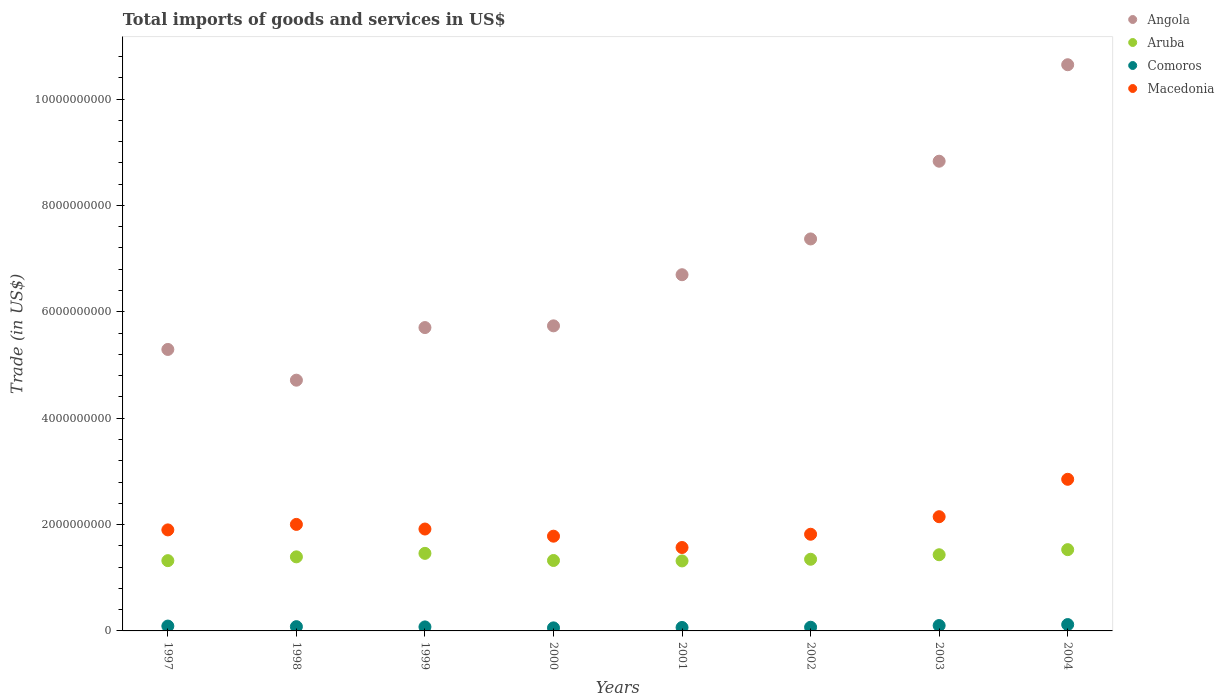How many different coloured dotlines are there?
Offer a very short reply. 4. What is the total imports of goods and services in Macedonia in 1997?
Offer a very short reply. 1.90e+09. Across all years, what is the maximum total imports of goods and services in Macedonia?
Offer a very short reply. 2.85e+09. Across all years, what is the minimum total imports of goods and services in Macedonia?
Make the answer very short. 1.57e+09. In which year was the total imports of goods and services in Macedonia maximum?
Your response must be concise. 2004. In which year was the total imports of goods and services in Macedonia minimum?
Your response must be concise. 2001. What is the total total imports of goods and services in Macedonia in the graph?
Ensure brevity in your answer.  1.60e+1. What is the difference between the total imports of goods and services in Angola in 2000 and that in 2001?
Ensure brevity in your answer.  -9.61e+08. What is the difference between the total imports of goods and services in Angola in 2004 and the total imports of goods and services in Aruba in 2002?
Give a very brief answer. 9.30e+09. What is the average total imports of goods and services in Angola per year?
Your response must be concise. 6.87e+09. In the year 2004, what is the difference between the total imports of goods and services in Macedonia and total imports of goods and services in Comoros?
Offer a very short reply. 2.73e+09. In how many years, is the total imports of goods and services in Macedonia greater than 8000000000 US$?
Ensure brevity in your answer.  0. What is the ratio of the total imports of goods and services in Comoros in 1999 to that in 2004?
Keep it short and to the point. 0.63. What is the difference between the highest and the second highest total imports of goods and services in Angola?
Your answer should be compact. 1.81e+09. What is the difference between the highest and the lowest total imports of goods and services in Macedonia?
Offer a terse response. 1.28e+09. In how many years, is the total imports of goods and services in Aruba greater than the average total imports of goods and services in Aruba taken over all years?
Your answer should be very brief. 4. Is it the case that in every year, the sum of the total imports of goods and services in Comoros and total imports of goods and services in Angola  is greater than the total imports of goods and services in Aruba?
Give a very brief answer. Yes. How many years are there in the graph?
Keep it short and to the point. 8. What is the difference between two consecutive major ticks on the Y-axis?
Ensure brevity in your answer.  2.00e+09. Are the values on the major ticks of Y-axis written in scientific E-notation?
Your response must be concise. No. Does the graph contain grids?
Provide a succinct answer. No. Where does the legend appear in the graph?
Offer a very short reply. Top right. How many legend labels are there?
Give a very brief answer. 4. What is the title of the graph?
Offer a very short reply. Total imports of goods and services in US$. What is the label or title of the X-axis?
Make the answer very short. Years. What is the label or title of the Y-axis?
Offer a terse response. Trade (in US$). What is the Trade (in US$) in Angola in 1997?
Make the answer very short. 5.29e+09. What is the Trade (in US$) of Aruba in 1997?
Offer a terse response. 1.32e+09. What is the Trade (in US$) of Comoros in 1997?
Offer a terse response. 9.13e+07. What is the Trade (in US$) in Macedonia in 1997?
Ensure brevity in your answer.  1.90e+09. What is the Trade (in US$) of Angola in 1998?
Your answer should be very brief. 4.71e+09. What is the Trade (in US$) in Aruba in 1998?
Give a very brief answer. 1.39e+09. What is the Trade (in US$) in Comoros in 1998?
Ensure brevity in your answer.  8.02e+07. What is the Trade (in US$) of Macedonia in 1998?
Provide a short and direct response. 2.00e+09. What is the Trade (in US$) in Angola in 1999?
Your answer should be compact. 5.70e+09. What is the Trade (in US$) of Aruba in 1999?
Make the answer very short. 1.46e+09. What is the Trade (in US$) of Comoros in 1999?
Offer a very short reply. 7.55e+07. What is the Trade (in US$) of Macedonia in 1999?
Your answer should be compact. 1.92e+09. What is the Trade (in US$) in Angola in 2000?
Your answer should be very brief. 5.74e+09. What is the Trade (in US$) in Aruba in 2000?
Give a very brief answer. 1.32e+09. What is the Trade (in US$) of Comoros in 2000?
Provide a short and direct response. 5.73e+07. What is the Trade (in US$) of Macedonia in 2000?
Offer a very short reply. 1.78e+09. What is the Trade (in US$) in Angola in 2001?
Keep it short and to the point. 6.70e+09. What is the Trade (in US$) of Aruba in 2001?
Your response must be concise. 1.32e+09. What is the Trade (in US$) in Comoros in 2001?
Provide a succinct answer. 6.50e+07. What is the Trade (in US$) of Macedonia in 2001?
Keep it short and to the point. 1.57e+09. What is the Trade (in US$) of Angola in 2002?
Offer a terse response. 7.37e+09. What is the Trade (in US$) of Aruba in 2002?
Provide a short and direct response. 1.35e+09. What is the Trade (in US$) in Comoros in 2002?
Keep it short and to the point. 6.95e+07. What is the Trade (in US$) of Macedonia in 2002?
Your answer should be very brief. 1.82e+09. What is the Trade (in US$) in Angola in 2003?
Provide a short and direct response. 8.83e+09. What is the Trade (in US$) in Aruba in 2003?
Ensure brevity in your answer.  1.43e+09. What is the Trade (in US$) of Comoros in 2003?
Offer a very short reply. 1.01e+08. What is the Trade (in US$) of Macedonia in 2003?
Your response must be concise. 2.15e+09. What is the Trade (in US$) in Angola in 2004?
Provide a short and direct response. 1.06e+1. What is the Trade (in US$) of Aruba in 2004?
Make the answer very short. 1.53e+09. What is the Trade (in US$) in Comoros in 2004?
Ensure brevity in your answer.  1.20e+08. What is the Trade (in US$) of Macedonia in 2004?
Offer a terse response. 2.85e+09. Across all years, what is the maximum Trade (in US$) in Angola?
Provide a succinct answer. 1.06e+1. Across all years, what is the maximum Trade (in US$) of Aruba?
Provide a succinct answer. 1.53e+09. Across all years, what is the maximum Trade (in US$) of Comoros?
Your answer should be very brief. 1.20e+08. Across all years, what is the maximum Trade (in US$) of Macedonia?
Provide a succinct answer. 2.85e+09. Across all years, what is the minimum Trade (in US$) in Angola?
Provide a short and direct response. 4.71e+09. Across all years, what is the minimum Trade (in US$) in Aruba?
Ensure brevity in your answer.  1.32e+09. Across all years, what is the minimum Trade (in US$) in Comoros?
Offer a very short reply. 5.73e+07. Across all years, what is the minimum Trade (in US$) of Macedonia?
Keep it short and to the point. 1.57e+09. What is the total Trade (in US$) in Angola in the graph?
Provide a short and direct response. 5.50e+1. What is the total Trade (in US$) in Aruba in the graph?
Keep it short and to the point. 1.11e+1. What is the total Trade (in US$) in Comoros in the graph?
Offer a very short reply. 6.59e+08. What is the total Trade (in US$) of Macedonia in the graph?
Your response must be concise. 1.60e+1. What is the difference between the Trade (in US$) of Angola in 1997 and that in 1998?
Ensure brevity in your answer.  5.78e+08. What is the difference between the Trade (in US$) in Aruba in 1997 and that in 1998?
Make the answer very short. -7.15e+07. What is the difference between the Trade (in US$) in Comoros in 1997 and that in 1998?
Your response must be concise. 1.10e+07. What is the difference between the Trade (in US$) of Macedonia in 1997 and that in 1998?
Provide a succinct answer. -1.03e+08. What is the difference between the Trade (in US$) of Angola in 1997 and that in 1999?
Keep it short and to the point. -4.11e+08. What is the difference between the Trade (in US$) of Aruba in 1997 and that in 1999?
Ensure brevity in your answer.  -1.37e+08. What is the difference between the Trade (in US$) in Comoros in 1997 and that in 1999?
Your response must be concise. 1.58e+07. What is the difference between the Trade (in US$) of Macedonia in 1997 and that in 1999?
Make the answer very short. -1.64e+07. What is the difference between the Trade (in US$) in Angola in 1997 and that in 2000?
Ensure brevity in your answer.  -4.44e+08. What is the difference between the Trade (in US$) of Aruba in 1997 and that in 2000?
Give a very brief answer. -3.06e+06. What is the difference between the Trade (in US$) of Comoros in 1997 and that in 2000?
Your answer should be compact. 3.40e+07. What is the difference between the Trade (in US$) in Macedonia in 1997 and that in 2000?
Your answer should be compact. 1.18e+08. What is the difference between the Trade (in US$) in Angola in 1997 and that in 2001?
Keep it short and to the point. -1.41e+09. What is the difference between the Trade (in US$) in Aruba in 1997 and that in 2001?
Your response must be concise. 5.20e+06. What is the difference between the Trade (in US$) of Comoros in 1997 and that in 2001?
Give a very brief answer. 2.63e+07. What is the difference between the Trade (in US$) in Macedonia in 1997 and that in 2001?
Offer a terse response. 3.31e+08. What is the difference between the Trade (in US$) of Angola in 1997 and that in 2002?
Your answer should be very brief. -2.08e+09. What is the difference between the Trade (in US$) of Aruba in 1997 and that in 2002?
Offer a terse response. -2.59e+07. What is the difference between the Trade (in US$) in Comoros in 1997 and that in 2002?
Your answer should be very brief. 2.18e+07. What is the difference between the Trade (in US$) of Macedonia in 1997 and that in 2002?
Your answer should be compact. 8.18e+07. What is the difference between the Trade (in US$) in Angola in 1997 and that in 2003?
Offer a very short reply. -3.54e+09. What is the difference between the Trade (in US$) in Aruba in 1997 and that in 2003?
Provide a short and direct response. -1.11e+08. What is the difference between the Trade (in US$) in Comoros in 1997 and that in 2003?
Make the answer very short. -9.95e+06. What is the difference between the Trade (in US$) of Macedonia in 1997 and that in 2003?
Make the answer very short. -2.48e+08. What is the difference between the Trade (in US$) of Angola in 1997 and that in 2004?
Give a very brief answer. -5.35e+09. What is the difference between the Trade (in US$) of Aruba in 1997 and that in 2004?
Offer a terse response. -2.07e+08. What is the difference between the Trade (in US$) in Comoros in 1997 and that in 2004?
Provide a succinct answer. -2.83e+07. What is the difference between the Trade (in US$) in Macedonia in 1997 and that in 2004?
Offer a terse response. -9.51e+08. What is the difference between the Trade (in US$) of Angola in 1998 and that in 1999?
Give a very brief answer. -9.89e+08. What is the difference between the Trade (in US$) of Aruba in 1998 and that in 1999?
Provide a succinct answer. -6.55e+07. What is the difference between the Trade (in US$) of Comoros in 1998 and that in 1999?
Ensure brevity in your answer.  4.76e+06. What is the difference between the Trade (in US$) of Macedonia in 1998 and that in 1999?
Ensure brevity in your answer.  8.71e+07. What is the difference between the Trade (in US$) of Angola in 1998 and that in 2000?
Ensure brevity in your answer.  -1.02e+09. What is the difference between the Trade (in US$) in Aruba in 1998 and that in 2000?
Your response must be concise. 6.85e+07. What is the difference between the Trade (in US$) of Comoros in 1998 and that in 2000?
Offer a very short reply. 2.29e+07. What is the difference between the Trade (in US$) in Macedonia in 1998 and that in 2000?
Your response must be concise. 2.22e+08. What is the difference between the Trade (in US$) in Angola in 1998 and that in 2001?
Make the answer very short. -1.98e+09. What is the difference between the Trade (in US$) in Aruba in 1998 and that in 2001?
Offer a very short reply. 7.67e+07. What is the difference between the Trade (in US$) of Comoros in 1998 and that in 2001?
Provide a short and direct response. 1.53e+07. What is the difference between the Trade (in US$) in Macedonia in 1998 and that in 2001?
Provide a succinct answer. 4.34e+08. What is the difference between the Trade (in US$) of Angola in 1998 and that in 2002?
Your answer should be compact. -2.66e+09. What is the difference between the Trade (in US$) in Aruba in 1998 and that in 2002?
Offer a terse response. 4.56e+07. What is the difference between the Trade (in US$) of Comoros in 1998 and that in 2002?
Offer a very short reply. 1.08e+07. What is the difference between the Trade (in US$) of Macedonia in 1998 and that in 2002?
Your response must be concise. 1.85e+08. What is the difference between the Trade (in US$) in Angola in 1998 and that in 2003?
Offer a terse response. -4.12e+09. What is the difference between the Trade (in US$) in Aruba in 1998 and that in 2003?
Your response must be concise. -3.94e+07. What is the difference between the Trade (in US$) in Comoros in 1998 and that in 2003?
Your response must be concise. -2.10e+07. What is the difference between the Trade (in US$) of Macedonia in 1998 and that in 2003?
Your answer should be very brief. -1.44e+08. What is the difference between the Trade (in US$) in Angola in 1998 and that in 2004?
Your answer should be very brief. -5.93e+09. What is the difference between the Trade (in US$) in Aruba in 1998 and that in 2004?
Make the answer very short. -1.35e+08. What is the difference between the Trade (in US$) of Comoros in 1998 and that in 2004?
Offer a very short reply. -3.93e+07. What is the difference between the Trade (in US$) of Macedonia in 1998 and that in 2004?
Your answer should be very brief. -8.48e+08. What is the difference between the Trade (in US$) in Angola in 1999 and that in 2000?
Make the answer very short. -3.23e+07. What is the difference between the Trade (in US$) in Aruba in 1999 and that in 2000?
Give a very brief answer. 1.34e+08. What is the difference between the Trade (in US$) of Comoros in 1999 and that in 2000?
Your response must be concise. 1.82e+07. What is the difference between the Trade (in US$) in Macedonia in 1999 and that in 2000?
Your answer should be compact. 1.34e+08. What is the difference between the Trade (in US$) in Angola in 1999 and that in 2001?
Keep it short and to the point. -9.94e+08. What is the difference between the Trade (in US$) in Aruba in 1999 and that in 2001?
Ensure brevity in your answer.  1.42e+08. What is the difference between the Trade (in US$) in Comoros in 1999 and that in 2001?
Give a very brief answer. 1.05e+07. What is the difference between the Trade (in US$) of Macedonia in 1999 and that in 2001?
Offer a terse response. 3.47e+08. What is the difference between the Trade (in US$) of Angola in 1999 and that in 2002?
Your response must be concise. -1.67e+09. What is the difference between the Trade (in US$) of Aruba in 1999 and that in 2002?
Offer a terse response. 1.11e+08. What is the difference between the Trade (in US$) in Comoros in 1999 and that in 2002?
Offer a terse response. 5.99e+06. What is the difference between the Trade (in US$) in Macedonia in 1999 and that in 2002?
Your answer should be compact. 9.81e+07. What is the difference between the Trade (in US$) of Angola in 1999 and that in 2003?
Make the answer very short. -3.13e+09. What is the difference between the Trade (in US$) in Aruba in 1999 and that in 2003?
Your answer should be very brief. 2.60e+07. What is the difference between the Trade (in US$) in Comoros in 1999 and that in 2003?
Your response must be concise. -2.57e+07. What is the difference between the Trade (in US$) in Macedonia in 1999 and that in 2003?
Provide a succinct answer. -2.32e+08. What is the difference between the Trade (in US$) of Angola in 1999 and that in 2004?
Your answer should be very brief. -4.94e+09. What is the difference between the Trade (in US$) of Aruba in 1999 and that in 2004?
Offer a terse response. -6.98e+07. What is the difference between the Trade (in US$) of Comoros in 1999 and that in 2004?
Offer a terse response. -4.40e+07. What is the difference between the Trade (in US$) of Macedonia in 1999 and that in 2004?
Offer a very short reply. -9.35e+08. What is the difference between the Trade (in US$) of Angola in 2000 and that in 2001?
Provide a succinct answer. -9.61e+08. What is the difference between the Trade (in US$) in Aruba in 2000 and that in 2001?
Offer a terse response. 8.25e+06. What is the difference between the Trade (in US$) in Comoros in 2000 and that in 2001?
Make the answer very short. -7.68e+06. What is the difference between the Trade (in US$) of Macedonia in 2000 and that in 2001?
Keep it short and to the point. 2.13e+08. What is the difference between the Trade (in US$) of Angola in 2000 and that in 2002?
Make the answer very short. -1.63e+09. What is the difference between the Trade (in US$) in Aruba in 2000 and that in 2002?
Keep it short and to the point. -2.28e+07. What is the difference between the Trade (in US$) of Comoros in 2000 and that in 2002?
Ensure brevity in your answer.  -1.22e+07. What is the difference between the Trade (in US$) of Macedonia in 2000 and that in 2002?
Your answer should be compact. -3.63e+07. What is the difference between the Trade (in US$) in Angola in 2000 and that in 2003?
Offer a terse response. -3.10e+09. What is the difference between the Trade (in US$) of Aruba in 2000 and that in 2003?
Give a very brief answer. -1.08e+08. What is the difference between the Trade (in US$) of Comoros in 2000 and that in 2003?
Ensure brevity in your answer.  -4.39e+07. What is the difference between the Trade (in US$) of Macedonia in 2000 and that in 2003?
Give a very brief answer. -3.66e+08. What is the difference between the Trade (in US$) in Angola in 2000 and that in 2004?
Keep it short and to the point. -4.91e+09. What is the difference between the Trade (in US$) in Aruba in 2000 and that in 2004?
Provide a short and direct response. -2.04e+08. What is the difference between the Trade (in US$) in Comoros in 2000 and that in 2004?
Ensure brevity in your answer.  -6.22e+07. What is the difference between the Trade (in US$) of Macedonia in 2000 and that in 2004?
Ensure brevity in your answer.  -1.07e+09. What is the difference between the Trade (in US$) of Angola in 2001 and that in 2002?
Make the answer very short. -6.73e+08. What is the difference between the Trade (in US$) in Aruba in 2001 and that in 2002?
Provide a succinct answer. -3.11e+07. What is the difference between the Trade (in US$) of Comoros in 2001 and that in 2002?
Offer a very short reply. -4.51e+06. What is the difference between the Trade (in US$) of Macedonia in 2001 and that in 2002?
Offer a terse response. -2.49e+08. What is the difference between the Trade (in US$) in Angola in 2001 and that in 2003?
Your response must be concise. -2.13e+09. What is the difference between the Trade (in US$) of Aruba in 2001 and that in 2003?
Provide a short and direct response. -1.16e+08. What is the difference between the Trade (in US$) of Comoros in 2001 and that in 2003?
Provide a succinct answer. -3.62e+07. What is the difference between the Trade (in US$) of Macedonia in 2001 and that in 2003?
Your answer should be compact. -5.79e+08. What is the difference between the Trade (in US$) in Angola in 2001 and that in 2004?
Your answer should be very brief. -3.95e+09. What is the difference between the Trade (in US$) of Aruba in 2001 and that in 2004?
Your answer should be very brief. -2.12e+08. What is the difference between the Trade (in US$) in Comoros in 2001 and that in 2004?
Provide a succinct answer. -5.45e+07. What is the difference between the Trade (in US$) of Macedonia in 2001 and that in 2004?
Your answer should be very brief. -1.28e+09. What is the difference between the Trade (in US$) in Angola in 2002 and that in 2003?
Your response must be concise. -1.46e+09. What is the difference between the Trade (in US$) of Aruba in 2002 and that in 2003?
Your response must be concise. -8.50e+07. What is the difference between the Trade (in US$) of Comoros in 2002 and that in 2003?
Offer a terse response. -3.17e+07. What is the difference between the Trade (in US$) of Macedonia in 2002 and that in 2003?
Provide a short and direct response. -3.30e+08. What is the difference between the Trade (in US$) of Angola in 2002 and that in 2004?
Give a very brief answer. -3.28e+09. What is the difference between the Trade (in US$) of Aruba in 2002 and that in 2004?
Provide a short and direct response. -1.81e+08. What is the difference between the Trade (in US$) of Comoros in 2002 and that in 2004?
Offer a terse response. -5.00e+07. What is the difference between the Trade (in US$) in Macedonia in 2002 and that in 2004?
Offer a terse response. -1.03e+09. What is the difference between the Trade (in US$) of Angola in 2003 and that in 2004?
Make the answer very short. -1.81e+09. What is the difference between the Trade (in US$) in Aruba in 2003 and that in 2004?
Give a very brief answer. -9.58e+07. What is the difference between the Trade (in US$) of Comoros in 2003 and that in 2004?
Your response must be concise. -1.83e+07. What is the difference between the Trade (in US$) of Macedonia in 2003 and that in 2004?
Your answer should be compact. -7.03e+08. What is the difference between the Trade (in US$) in Angola in 1997 and the Trade (in US$) in Aruba in 1998?
Offer a terse response. 3.90e+09. What is the difference between the Trade (in US$) in Angola in 1997 and the Trade (in US$) in Comoros in 1998?
Offer a terse response. 5.21e+09. What is the difference between the Trade (in US$) in Angola in 1997 and the Trade (in US$) in Macedonia in 1998?
Provide a short and direct response. 3.29e+09. What is the difference between the Trade (in US$) in Aruba in 1997 and the Trade (in US$) in Comoros in 1998?
Offer a terse response. 1.24e+09. What is the difference between the Trade (in US$) in Aruba in 1997 and the Trade (in US$) in Macedonia in 1998?
Your answer should be very brief. -6.82e+08. What is the difference between the Trade (in US$) in Comoros in 1997 and the Trade (in US$) in Macedonia in 1998?
Provide a short and direct response. -1.91e+09. What is the difference between the Trade (in US$) in Angola in 1997 and the Trade (in US$) in Aruba in 1999?
Keep it short and to the point. 3.83e+09. What is the difference between the Trade (in US$) of Angola in 1997 and the Trade (in US$) of Comoros in 1999?
Your response must be concise. 5.22e+09. What is the difference between the Trade (in US$) in Angola in 1997 and the Trade (in US$) in Macedonia in 1999?
Offer a terse response. 3.38e+09. What is the difference between the Trade (in US$) of Aruba in 1997 and the Trade (in US$) of Comoros in 1999?
Your answer should be compact. 1.25e+09. What is the difference between the Trade (in US$) of Aruba in 1997 and the Trade (in US$) of Macedonia in 1999?
Offer a terse response. -5.95e+08. What is the difference between the Trade (in US$) of Comoros in 1997 and the Trade (in US$) of Macedonia in 1999?
Your response must be concise. -1.82e+09. What is the difference between the Trade (in US$) in Angola in 1997 and the Trade (in US$) in Aruba in 2000?
Your response must be concise. 3.97e+09. What is the difference between the Trade (in US$) of Angola in 1997 and the Trade (in US$) of Comoros in 2000?
Ensure brevity in your answer.  5.23e+09. What is the difference between the Trade (in US$) of Angola in 1997 and the Trade (in US$) of Macedonia in 2000?
Your answer should be compact. 3.51e+09. What is the difference between the Trade (in US$) in Aruba in 1997 and the Trade (in US$) in Comoros in 2000?
Provide a short and direct response. 1.26e+09. What is the difference between the Trade (in US$) in Aruba in 1997 and the Trade (in US$) in Macedonia in 2000?
Provide a short and direct response. -4.60e+08. What is the difference between the Trade (in US$) in Comoros in 1997 and the Trade (in US$) in Macedonia in 2000?
Your answer should be compact. -1.69e+09. What is the difference between the Trade (in US$) of Angola in 1997 and the Trade (in US$) of Aruba in 2001?
Ensure brevity in your answer.  3.98e+09. What is the difference between the Trade (in US$) of Angola in 1997 and the Trade (in US$) of Comoros in 2001?
Provide a short and direct response. 5.23e+09. What is the difference between the Trade (in US$) in Angola in 1997 and the Trade (in US$) in Macedonia in 2001?
Give a very brief answer. 3.72e+09. What is the difference between the Trade (in US$) in Aruba in 1997 and the Trade (in US$) in Comoros in 2001?
Keep it short and to the point. 1.26e+09. What is the difference between the Trade (in US$) in Aruba in 1997 and the Trade (in US$) in Macedonia in 2001?
Offer a terse response. -2.47e+08. What is the difference between the Trade (in US$) in Comoros in 1997 and the Trade (in US$) in Macedonia in 2001?
Your answer should be very brief. -1.48e+09. What is the difference between the Trade (in US$) in Angola in 1997 and the Trade (in US$) in Aruba in 2002?
Provide a short and direct response. 3.95e+09. What is the difference between the Trade (in US$) of Angola in 1997 and the Trade (in US$) of Comoros in 2002?
Your response must be concise. 5.22e+09. What is the difference between the Trade (in US$) of Angola in 1997 and the Trade (in US$) of Macedonia in 2002?
Offer a terse response. 3.47e+09. What is the difference between the Trade (in US$) in Aruba in 1997 and the Trade (in US$) in Comoros in 2002?
Keep it short and to the point. 1.25e+09. What is the difference between the Trade (in US$) of Aruba in 1997 and the Trade (in US$) of Macedonia in 2002?
Offer a terse response. -4.96e+08. What is the difference between the Trade (in US$) of Comoros in 1997 and the Trade (in US$) of Macedonia in 2002?
Keep it short and to the point. -1.73e+09. What is the difference between the Trade (in US$) of Angola in 1997 and the Trade (in US$) of Aruba in 2003?
Make the answer very short. 3.86e+09. What is the difference between the Trade (in US$) in Angola in 1997 and the Trade (in US$) in Comoros in 2003?
Your answer should be compact. 5.19e+09. What is the difference between the Trade (in US$) of Angola in 1997 and the Trade (in US$) of Macedonia in 2003?
Your answer should be compact. 3.14e+09. What is the difference between the Trade (in US$) in Aruba in 1997 and the Trade (in US$) in Comoros in 2003?
Keep it short and to the point. 1.22e+09. What is the difference between the Trade (in US$) of Aruba in 1997 and the Trade (in US$) of Macedonia in 2003?
Your answer should be compact. -8.26e+08. What is the difference between the Trade (in US$) of Comoros in 1997 and the Trade (in US$) of Macedonia in 2003?
Offer a very short reply. -2.06e+09. What is the difference between the Trade (in US$) of Angola in 1997 and the Trade (in US$) of Aruba in 2004?
Offer a terse response. 3.76e+09. What is the difference between the Trade (in US$) of Angola in 1997 and the Trade (in US$) of Comoros in 2004?
Ensure brevity in your answer.  5.17e+09. What is the difference between the Trade (in US$) in Angola in 1997 and the Trade (in US$) in Macedonia in 2004?
Provide a succinct answer. 2.44e+09. What is the difference between the Trade (in US$) in Aruba in 1997 and the Trade (in US$) in Comoros in 2004?
Your answer should be compact. 1.20e+09. What is the difference between the Trade (in US$) in Aruba in 1997 and the Trade (in US$) in Macedonia in 2004?
Your response must be concise. -1.53e+09. What is the difference between the Trade (in US$) of Comoros in 1997 and the Trade (in US$) of Macedonia in 2004?
Ensure brevity in your answer.  -2.76e+09. What is the difference between the Trade (in US$) of Angola in 1998 and the Trade (in US$) of Aruba in 1999?
Your response must be concise. 3.26e+09. What is the difference between the Trade (in US$) of Angola in 1998 and the Trade (in US$) of Comoros in 1999?
Provide a succinct answer. 4.64e+09. What is the difference between the Trade (in US$) of Angola in 1998 and the Trade (in US$) of Macedonia in 1999?
Offer a terse response. 2.80e+09. What is the difference between the Trade (in US$) in Aruba in 1998 and the Trade (in US$) in Comoros in 1999?
Offer a terse response. 1.32e+09. What is the difference between the Trade (in US$) in Aruba in 1998 and the Trade (in US$) in Macedonia in 1999?
Provide a short and direct response. -5.23e+08. What is the difference between the Trade (in US$) of Comoros in 1998 and the Trade (in US$) of Macedonia in 1999?
Ensure brevity in your answer.  -1.84e+09. What is the difference between the Trade (in US$) in Angola in 1998 and the Trade (in US$) in Aruba in 2000?
Keep it short and to the point. 3.39e+09. What is the difference between the Trade (in US$) of Angola in 1998 and the Trade (in US$) of Comoros in 2000?
Keep it short and to the point. 4.66e+09. What is the difference between the Trade (in US$) of Angola in 1998 and the Trade (in US$) of Macedonia in 2000?
Your answer should be very brief. 2.93e+09. What is the difference between the Trade (in US$) in Aruba in 1998 and the Trade (in US$) in Comoros in 2000?
Offer a very short reply. 1.34e+09. What is the difference between the Trade (in US$) in Aruba in 1998 and the Trade (in US$) in Macedonia in 2000?
Give a very brief answer. -3.89e+08. What is the difference between the Trade (in US$) in Comoros in 1998 and the Trade (in US$) in Macedonia in 2000?
Ensure brevity in your answer.  -1.70e+09. What is the difference between the Trade (in US$) of Angola in 1998 and the Trade (in US$) of Aruba in 2001?
Provide a succinct answer. 3.40e+09. What is the difference between the Trade (in US$) of Angola in 1998 and the Trade (in US$) of Comoros in 2001?
Your answer should be very brief. 4.65e+09. What is the difference between the Trade (in US$) of Angola in 1998 and the Trade (in US$) of Macedonia in 2001?
Provide a short and direct response. 3.15e+09. What is the difference between the Trade (in US$) in Aruba in 1998 and the Trade (in US$) in Comoros in 2001?
Offer a terse response. 1.33e+09. What is the difference between the Trade (in US$) in Aruba in 1998 and the Trade (in US$) in Macedonia in 2001?
Give a very brief answer. -1.76e+08. What is the difference between the Trade (in US$) of Comoros in 1998 and the Trade (in US$) of Macedonia in 2001?
Your answer should be compact. -1.49e+09. What is the difference between the Trade (in US$) in Angola in 1998 and the Trade (in US$) in Aruba in 2002?
Offer a very short reply. 3.37e+09. What is the difference between the Trade (in US$) of Angola in 1998 and the Trade (in US$) of Comoros in 2002?
Offer a very short reply. 4.64e+09. What is the difference between the Trade (in US$) in Angola in 1998 and the Trade (in US$) in Macedonia in 2002?
Your response must be concise. 2.90e+09. What is the difference between the Trade (in US$) in Aruba in 1998 and the Trade (in US$) in Comoros in 2002?
Your answer should be compact. 1.32e+09. What is the difference between the Trade (in US$) of Aruba in 1998 and the Trade (in US$) of Macedonia in 2002?
Provide a short and direct response. -4.25e+08. What is the difference between the Trade (in US$) of Comoros in 1998 and the Trade (in US$) of Macedonia in 2002?
Ensure brevity in your answer.  -1.74e+09. What is the difference between the Trade (in US$) in Angola in 1998 and the Trade (in US$) in Aruba in 2003?
Your answer should be compact. 3.28e+09. What is the difference between the Trade (in US$) in Angola in 1998 and the Trade (in US$) in Comoros in 2003?
Offer a very short reply. 4.61e+09. What is the difference between the Trade (in US$) of Angola in 1998 and the Trade (in US$) of Macedonia in 2003?
Keep it short and to the point. 2.57e+09. What is the difference between the Trade (in US$) of Aruba in 1998 and the Trade (in US$) of Comoros in 2003?
Keep it short and to the point. 1.29e+09. What is the difference between the Trade (in US$) of Aruba in 1998 and the Trade (in US$) of Macedonia in 2003?
Offer a terse response. -7.55e+08. What is the difference between the Trade (in US$) in Comoros in 1998 and the Trade (in US$) in Macedonia in 2003?
Provide a succinct answer. -2.07e+09. What is the difference between the Trade (in US$) of Angola in 1998 and the Trade (in US$) of Aruba in 2004?
Provide a short and direct response. 3.19e+09. What is the difference between the Trade (in US$) of Angola in 1998 and the Trade (in US$) of Comoros in 2004?
Give a very brief answer. 4.59e+09. What is the difference between the Trade (in US$) in Angola in 1998 and the Trade (in US$) in Macedonia in 2004?
Provide a short and direct response. 1.86e+09. What is the difference between the Trade (in US$) in Aruba in 1998 and the Trade (in US$) in Comoros in 2004?
Give a very brief answer. 1.27e+09. What is the difference between the Trade (in US$) of Aruba in 1998 and the Trade (in US$) of Macedonia in 2004?
Make the answer very short. -1.46e+09. What is the difference between the Trade (in US$) in Comoros in 1998 and the Trade (in US$) in Macedonia in 2004?
Your answer should be compact. -2.77e+09. What is the difference between the Trade (in US$) of Angola in 1999 and the Trade (in US$) of Aruba in 2000?
Your response must be concise. 4.38e+09. What is the difference between the Trade (in US$) of Angola in 1999 and the Trade (in US$) of Comoros in 2000?
Ensure brevity in your answer.  5.65e+09. What is the difference between the Trade (in US$) in Angola in 1999 and the Trade (in US$) in Macedonia in 2000?
Your response must be concise. 3.92e+09. What is the difference between the Trade (in US$) of Aruba in 1999 and the Trade (in US$) of Comoros in 2000?
Provide a short and direct response. 1.40e+09. What is the difference between the Trade (in US$) of Aruba in 1999 and the Trade (in US$) of Macedonia in 2000?
Provide a succinct answer. -3.23e+08. What is the difference between the Trade (in US$) in Comoros in 1999 and the Trade (in US$) in Macedonia in 2000?
Offer a very short reply. -1.71e+09. What is the difference between the Trade (in US$) of Angola in 1999 and the Trade (in US$) of Aruba in 2001?
Provide a succinct answer. 4.39e+09. What is the difference between the Trade (in US$) in Angola in 1999 and the Trade (in US$) in Comoros in 2001?
Offer a terse response. 5.64e+09. What is the difference between the Trade (in US$) in Angola in 1999 and the Trade (in US$) in Macedonia in 2001?
Keep it short and to the point. 4.14e+09. What is the difference between the Trade (in US$) in Aruba in 1999 and the Trade (in US$) in Comoros in 2001?
Offer a very short reply. 1.39e+09. What is the difference between the Trade (in US$) in Aruba in 1999 and the Trade (in US$) in Macedonia in 2001?
Give a very brief answer. -1.10e+08. What is the difference between the Trade (in US$) of Comoros in 1999 and the Trade (in US$) of Macedonia in 2001?
Your response must be concise. -1.49e+09. What is the difference between the Trade (in US$) in Angola in 1999 and the Trade (in US$) in Aruba in 2002?
Your answer should be compact. 4.36e+09. What is the difference between the Trade (in US$) in Angola in 1999 and the Trade (in US$) in Comoros in 2002?
Your answer should be very brief. 5.63e+09. What is the difference between the Trade (in US$) in Angola in 1999 and the Trade (in US$) in Macedonia in 2002?
Give a very brief answer. 3.89e+09. What is the difference between the Trade (in US$) of Aruba in 1999 and the Trade (in US$) of Comoros in 2002?
Provide a succinct answer. 1.39e+09. What is the difference between the Trade (in US$) in Aruba in 1999 and the Trade (in US$) in Macedonia in 2002?
Make the answer very short. -3.59e+08. What is the difference between the Trade (in US$) in Comoros in 1999 and the Trade (in US$) in Macedonia in 2002?
Provide a succinct answer. -1.74e+09. What is the difference between the Trade (in US$) of Angola in 1999 and the Trade (in US$) of Aruba in 2003?
Your answer should be very brief. 4.27e+09. What is the difference between the Trade (in US$) in Angola in 1999 and the Trade (in US$) in Comoros in 2003?
Offer a terse response. 5.60e+09. What is the difference between the Trade (in US$) in Angola in 1999 and the Trade (in US$) in Macedonia in 2003?
Keep it short and to the point. 3.56e+09. What is the difference between the Trade (in US$) in Aruba in 1999 and the Trade (in US$) in Comoros in 2003?
Offer a very short reply. 1.36e+09. What is the difference between the Trade (in US$) of Aruba in 1999 and the Trade (in US$) of Macedonia in 2003?
Your response must be concise. -6.89e+08. What is the difference between the Trade (in US$) in Comoros in 1999 and the Trade (in US$) in Macedonia in 2003?
Provide a succinct answer. -2.07e+09. What is the difference between the Trade (in US$) of Angola in 1999 and the Trade (in US$) of Aruba in 2004?
Provide a succinct answer. 4.18e+09. What is the difference between the Trade (in US$) in Angola in 1999 and the Trade (in US$) in Comoros in 2004?
Offer a very short reply. 5.58e+09. What is the difference between the Trade (in US$) in Angola in 1999 and the Trade (in US$) in Macedonia in 2004?
Your answer should be compact. 2.85e+09. What is the difference between the Trade (in US$) of Aruba in 1999 and the Trade (in US$) of Comoros in 2004?
Ensure brevity in your answer.  1.34e+09. What is the difference between the Trade (in US$) of Aruba in 1999 and the Trade (in US$) of Macedonia in 2004?
Give a very brief answer. -1.39e+09. What is the difference between the Trade (in US$) in Comoros in 1999 and the Trade (in US$) in Macedonia in 2004?
Ensure brevity in your answer.  -2.78e+09. What is the difference between the Trade (in US$) in Angola in 2000 and the Trade (in US$) in Aruba in 2001?
Keep it short and to the point. 4.42e+09. What is the difference between the Trade (in US$) of Angola in 2000 and the Trade (in US$) of Comoros in 2001?
Give a very brief answer. 5.67e+09. What is the difference between the Trade (in US$) of Angola in 2000 and the Trade (in US$) of Macedonia in 2001?
Give a very brief answer. 4.17e+09. What is the difference between the Trade (in US$) in Aruba in 2000 and the Trade (in US$) in Comoros in 2001?
Your answer should be very brief. 1.26e+09. What is the difference between the Trade (in US$) of Aruba in 2000 and the Trade (in US$) of Macedonia in 2001?
Provide a short and direct response. -2.44e+08. What is the difference between the Trade (in US$) of Comoros in 2000 and the Trade (in US$) of Macedonia in 2001?
Offer a terse response. -1.51e+09. What is the difference between the Trade (in US$) of Angola in 2000 and the Trade (in US$) of Aruba in 2002?
Offer a very short reply. 4.39e+09. What is the difference between the Trade (in US$) of Angola in 2000 and the Trade (in US$) of Comoros in 2002?
Provide a succinct answer. 5.67e+09. What is the difference between the Trade (in US$) of Angola in 2000 and the Trade (in US$) of Macedonia in 2002?
Give a very brief answer. 3.92e+09. What is the difference between the Trade (in US$) of Aruba in 2000 and the Trade (in US$) of Comoros in 2002?
Offer a very short reply. 1.25e+09. What is the difference between the Trade (in US$) of Aruba in 2000 and the Trade (in US$) of Macedonia in 2002?
Offer a terse response. -4.93e+08. What is the difference between the Trade (in US$) of Comoros in 2000 and the Trade (in US$) of Macedonia in 2002?
Provide a short and direct response. -1.76e+09. What is the difference between the Trade (in US$) of Angola in 2000 and the Trade (in US$) of Aruba in 2003?
Provide a short and direct response. 4.30e+09. What is the difference between the Trade (in US$) in Angola in 2000 and the Trade (in US$) in Comoros in 2003?
Provide a short and direct response. 5.63e+09. What is the difference between the Trade (in US$) of Angola in 2000 and the Trade (in US$) of Macedonia in 2003?
Your answer should be compact. 3.59e+09. What is the difference between the Trade (in US$) in Aruba in 2000 and the Trade (in US$) in Comoros in 2003?
Keep it short and to the point. 1.22e+09. What is the difference between the Trade (in US$) of Aruba in 2000 and the Trade (in US$) of Macedonia in 2003?
Ensure brevity in your answer.  -8.23e+08. What is the difference between the Trade (in US$) in Comoros in 2000 and the Trade (in US$) in Macedonia in 2003?
Your response must be concise. -2.09e+09. What is the difference between the Trade (in US$) in Angola in 2000 and the Trade (in US$) in Aruba in 2004?
Provide a short and direct response. 4.21e+09. What is the difference between the Trade (in US$) of Angola in 2000 and the Trade (in US$) of Comoros in 2004?
Make the answer very short. 5.62e+09. What is the difference between the Trade (in US$) in Angola in 2000 and the Trade (in US$) in Macedonia in 2004?
Your response must be concise. 2.89e+09. What is the difference between the Trade (in US$) in Aruba in 2000 and the Trade (in US$) in Comoros in 2004?
Your answer should be compact. 1.20e+09. What is the difference between the Trade (in US$) in Aruba in 2000 and the Trade (in US$) in Macedonia in 2004?
Offer a terse response. -1.53e+09. What is the difference between the Trade (in US$) of Comoros in 2000 and the Trade (in US$) of Macedonia in 2004?
Give a very brief answer. -2.79e+09. What is the difference between the Trade (in US$) of Angola in 2001 and the Trade (in US$) of Aruba in 2002?
Your answer should be compact. 5.35e+09. What is the difference between the Trade (in US$) in Angola in 2001 and the Trade (in US$) in Comoros in 2002?
Your answer should be very brief. 6.63e+09. What is the difference between the Trade (in US$) in Angola in 2001 and the Trade (in US$) in Macedonia in 2002?
Offer a terse response. 4.88e+09. What is the difference between the Trade (in US$) of Aruba in 2001 and the Trade (in US$) of Comoros in 2002?
Keep it short and to the point. 1.25e+09. What is the difference between the Trade (in US$) in Aruba in 2001 and the Trade (in US$) in Macedonia in 2002?
Your answer should be very brief. -5.02e+08. What is the difference between the Trade (in US$) in Comoros in 2001 and the Trade (in US$) in Macedonia in 2002?
Your answer should be compact. -1.75e+09. What is the difference between the Trade (in US$) in Angola in 2001 and the Trade (in US$) in Aruba in 2003?
Your response must be concise. 5.27e+09. What is the difference between the Trade (in US$) of Angola in 2001 and the Trade (in US$) of Comoros in 2003?
Provide a short and direct response. 6.60e+09. What is the difference between the Trade (in US$) in Angola in 2001 and the Trade (in US$) in Macedonia in 2003?
Your answer should be very brief. 4.55e+09. What is the difference between the Trade (in US$) in Aruba in 2001 and the Trade (in US$) in Comoros in 2003?
Your response must be concise. 1.21e+09. What is the difference between the Trade (in US$) in Aruba in 2001 and the Trade (in US$) in Macedonia in 2003?
Provide a succinct answer. -8.31e+08. What is the difference between the Trade (in US$) of Comoros in 2001 and the Trade (in US$) of Macedonia in 2003?
Your answer should be compact. -2.08e+09. What is the difference between the Trade (in US$) of Angola in 2001 and the Trade (in US$) of Aruba in 2004?
Give a very brief answer. 5.17e+09. What is the difference between the Trade (in US$) in Angola in 2001 and the Trade (in US$) in Comoros in 2004?
Your response must be concise. 6.58e+09. What is the difference between the Trade (in US$) in Angola in 2001 and the Trade (in US$) in Macedonia in 2004?
Your response must be concise. 3.85e+09. What is the difference between the Trade (in US$) in Aruba in 2001 and the Trade (in US$) in Comoros in 2004?
Keep it short and to the point. 1.20e+09. What is the difference between the Trade (in US$) of Aruba in 2001 and the Trade (in US$) of Macedonia in 2004?
Offer a very short reply. -1.53e+09. What is the difference between the Trade (in US$) in Comoros in 2001 and the Trade (in US$) in Macedonia in 2004?
Your response must be concise. -2.79e+09. What is the difference between the Trade (in US$) of Angola in 2002 and the Trade (in US$) of Aruba in 2003?
Ensure brevity in your answer.  5.94e+09. What is the difference between the Trade (in US$) of Angola in 2002 and the Trade (in US$) of Comoros in 2003?
Your answer should be very brief. 7.27e+09. What is the difference between the Trade (in US$) in Angola in 2002 and the Trade (in US$) in Macedonia in 2003?
Provide a succinct answer. 5.22e+09. What is the difference between the Trade (in US$) in Aruba in 2002 and the Trade (in US$) in Comoros in 2003?
Keep it short and to the point. 1.25e+09. What is the difference between the Trade (in US$) of Aruba in 2002 and the Trade (in US$) of Macedonia in 2003?
Offer a terse response. -8.00e+08. What is the difference between the Trade (in US$) in Comoros in 2002 and the Trade (in US$) in Macedonia in 2003?
Your answer should be compact. -2.08e+09. What is the difference between the Trade (in US$) of Angola in 2002 and the Trade (in US$) of Aruba in 2004?
Your answer should be compact. 5.84e+09. What is the difference between the Trade (in US$) in Angola in 2002 and the Trade (in US$) in Comoros in 2004?
Your response must be concise. 7.25e+09. What is the difference between the Trade (in US$) of Angola in 2002 and the Trade (in US$) of Macedonia in 2004?
Your response must be concise. 4.52e+09. What is the difference between the Trade (in US$) in Aruba in 2002 and the Trade (in US$) in Comoros in 2004?
Offer a very short reply. 1.23e+09. What is the difference between the Trade (in US$) of Aruba in 2002 and the Trade (in US$) of Macedonia in 2004?
Give a very brief answer. -1.50e+09. What is the difference between the Trade (in US$) in Comoros in 2002 and the Trade (in US$) in Macedonia in 2004?
Your response must be concise. -2.78e+09. What is the difference between the Trade (in US$) of Angola in 2003 and the Trade (in US$) of Aruba in 2004?
Give a very brief answer. 7.30e+09. What is the difference between the Trade (in US$) of Angola in 2003 and the Trade (in US$) of Comoros in 2004?
Make the answer very short. 8.71e+09. What is the difference between the Trade (in US$) of Angola in 2003 and the Trade (in US$) of Macedonia in 2004?
Make the answer very short. 5.98e+09. What is the difference between the Trade (in US$) of Aruba in 2003 and the Trade (in US$) of Comoros in 2004?
Keep it short and to the point. 1.31e+09. What is the difference between the Trade (in US$) in Aruba in 2003 and the Trade (in US$) in Macedonia in 2004?
Provide a succinct answer. -1.42e+09. What is the difference between the Trade (in US$) of Comoros in 2003 and the Trade (in US$) of Macedonia in 2004?
Keep it short and to the point. -2.75e+09. What is the average Trade (in US$) in Angola per year?
Give a very brief answer. 6.87e+09. What is the average Trade (in US$) of Aruba per year?
Your response must be concise. 1.39e+09. What is the average Trade (in US$) of Comoros per year?
Keep it short and to the point. 8.24e+07. What is the average Trade (in US$) of Macedonia per year?
Your response must be concise. 2.00e+09. In the year 1997, what is the difference between the Trade (in US$) in Angola and Trade (in US$) in Aruba?
Provide a short and direct response. 3.97e+09. In the year 1997, what is the difference between the Trade (in US$) in Angola and Trade (in US$) in Comoros?
Your response must be concise. 5.20e+09. In the year 1997, what is the difference between the Trade (in US$) of Angola and Trade (in US$) of Macedonia?
Offer a terse response. 3.39e+09. In the year 1997, what is the difference between the Trade (in US$) of Aruba and Trade (in US$) of Comoros?
Your answer should be compact. 1.23e+09. In the year 1997, what is the difference between the Trade (in US$) in Aruba and Trade (in US$) in Macedonia?
Your answer should be compact. -5.78e+08. In the year 1997, what is the difference between the Trade (in US$) of Comoros and Trade (in US$) of Macedonia?
Provide a short and direct response. -1.81e+09. In the year 1998, what is the difference between the Trade (in US$) in Angola and Trade (in US$) in Aruba?
Offer a terse response. 3.32e+09. In the year 1998, what is the difference between the Trade (in US$) of Angola and Trade (in US$) of Comoros?
Ensure brevity in your answer.  4.63e+09. In the year 1998, what is the difference between the Trade (in US$) in Angola and Trade (in US$) in Macedonia?
Provide a succinct answer. 2.71e+09. In the year 1998, what is the difference between the Trade (in US$) in Aruba and Trade (in US$) in Comoros?
Your answer should be compact. 1.31e+09. In the year 1998, what is the difference between the Trade (in US$) in Aruba and Trade (in US$) in Macedonia?
Your answer should be compact. -6.10e+08. In the year 1998, what is the difference between the Trade (in US$) in Comoros and Trade (in US$) in Macedonia?
Your answer should be compact. -1.92e+09. In the year 1999, what is the difference between the Trade (in US$) of Angola and Trade (in US$) of Aruba?
Offer a very short reply. 4.25e+09. In the year 1999, what is the difference between the Trade (in US$) in Angola and Trade (in US$) in Comoros?
Your answer should be compact. 5.63e+09. In the year 1999, what is the difference between the Trade (in US$) in Angola and Trade (in US$) in Macedonia?
Offer a very short reply. 3.79e+09. In the year 1999, what is the difference between the Trade (in US$) in Aruba and Trade (in US$) in Comoros?
Your response must be concise. 1.38e+09. In the year 1999, what is the difference between the Trade (in US$) in Aruba and Trade (in US$) in Macedonia?
Provide a succinct answer. -4.58e+08. In the year 1999, what is the difference between the Trade (in US$) of Comoros and Trade (in US$) of Macedonia?
Offer a terse response. -1.84e+09. In the year 2000, what is the difference between the Trade (in US$) of Angola and Trade (in US$) of Aruba?
Keep it short and to the point. 4.41e+09. In the year 2000, what is the difference between the Trade (in US$) in Angola and Trade (in US$) in Comoros?
Offer a terse response. 5.68e+09. In the year 2000, what is the difference between the Trade (in US$) of Angola and Trade (in US$) of Macedonia?
Give a very brief answer. 3.95e+09. In the year 2000, what is the difference between the Trade (in US$) in Aruba and Trade (in US$) in Comoros?
Keep it short and to the point. 1.27e+09. In the year 2000, what is the difference between the Trade (in US$) in Aruba and Trade (in US$) in Macedonia?
Your answer should be compact. -4.57e+08. In the year 2000, what is the difference between the Trade (in US$) in Comoros and Trade (in US$) in Macedonia?
Your answer should be very brief. -1.72e+09. In the year 2001, what is the difference between the Trade (in US$) in Angola and Trade (in US$) in Aruba?
Keep it short and to the point. 5.38e+09. In the year 2001, what is the difference between the Trade (in US$) in Angola and Trade (in US$) in Comoros?
Offer a terse response. 6.63e+09. In the year 2001, what is the difference between the Trade (in US$) of Angola and Trade (in US$) of Macedonia?
Your response must be concise. 5.13e+09. In the year 2001, what is the difference between the Trade (in US$) in Aruba and Trade (in US$) in Comoros?
Keep it short and to the point. 1.25e+09. In the year 2001, what is the difference between the Trade (in US$) in Aruba and Trade (in US$) in Macedonia?
Offer a terse response. -2.52e+08. In the year 2001, what is the difference between the Trade (in US$) of Comoros and Trade (in US$) of Macedonia?
Your response must be concise. -1.50e+09. In the year 2002, what is the difference between the Trade (in US$) in Angola and Trade (in US$) in Aruba?
Ensure brevity in your answer.  6.02e+09. In the year 2002, what is the difference between the Trade (in US$) in Angola and Trade (in US$) in Comoros?
Ensure brevity in your answer.  7.30e+09. In the year 2002, what is the difference between the Trade (in US$) in Angola and Trade (in US$) in Macedonia?
Your answer should be very brief. 5.55e+09. In the year 2002, what is the difference between the Trade (in US$) of Aruba and Trade (in US$) of Comoros?
Your answer should be compact. 1.28e+09. In the year 2002, what is the difference between the Trade (in US$) in Aruba and Trade (in US$) in Macedonia?
Your answer should be very brief. -4.70e+08. In the year 2002, what is the difference between the Trade (in US$) of Comoros and Trade (in US$) of Macedonia?
Ensure brevity in your answer.  -1.75e+09. In the year 2003, what is the difference between the Trade (in US$) of Angola and Trade (in US$) of Aruba?
Keep it short and to the point. 7.40e+09. In the year 2003, what is the difference between the Trade (in US$) of Angola and Trade (in US$) of Comoros?
Ensure brevity in your answer.  8.73e+09. In the year 2003, what is the difference between the Trade (in US$) in Angola and Trade (in US$) in Macedonia?
Make the answer very short. 6.68e+09. In the year 2003, what is the difference between the Trade (in US$) in Aruba and Trade (in US$) in Comoros?
Your answer should be compact. 1.33e+09. In the year 2003, what is the difference between the Trade (in US$) of Aruba and Trade (in US$) of Macedonia?
Ensure brevity in your answer.  -7.15e+08. In the year 2003, what is the difference between the Trade (in US$) of Comoros and Trade (in US$) of Macedonia?
Offer a terse response. -2.05e+09. In the year 2004, what is the difference between the Trade (in US$) of Angola and Trade (in US$) of Aruba?
Offer a terse response. 9.12e+09. In the year 2004, what is the difference between the Trade (in US$) of Angola and Trade (in US$) of Comoros?
Offer a very short reply. 1.05e+1. In the year 2004, what is the difference between the Trade (in US$) in Angola and Trade (in US$) in Macedonia?
Give a very brief answer. 7.79e+09. In the year 2004, what is the difference between the Trade (in US$) in Aruba and Trade (in US$) in Comoros?
Offer a very short reply. 1.41e+09. In the year 2004, what is the difference between the Trade (in US$) of Aruba and Trade (in US$) of Macedonia?
Keep it short and to the point. -1.32e+09. In the year 2004, what is the difference between the Trade (in US$) in Comoros and Trade (in US$) in Macedonia?
Offer a very short reply. -2.73e+09. What is the ratio of the Trade (in US$) of Angola in 1997 to that in 1998?
Your answer should be very brief. 1.12. What is the ratio of the Trade (in US$) in Aruba in 1997 to that in 1998?
Your answer should be very brief. 0.95. What is the ratio of the Trade (in US$) in Comoros in 1997 to that in 1998?
Offer a very short reply. 1.14. What is the ratio of the Trade (in US$) in Macedonia in 1997 to that in 1998?
Offer a terse response. 0.95. What is the ratio of the Trade (in US$) of Angola in 1997 to that in 1999?
Offer a very short reply. 0.93. What is the ratio of the Trade (in US$) of Aruba in 1997 to that in 1999?
Give a very brief answer. 0.91. What is the ratio of the Trade (in US$) in Comoros in 1997 to that in 1999?
Your response must be concise. 1.21. What is the ratio of the Trade (in US$) of Macedonia in 1997 to that in 1999?
Offer a very short reply. 0.99. What is the ratio of the Trade (in US$) of Angola in 1997 to that in 2000?
Provide a short and direct response. 0.92. What is the ratio of the Trade (in US$) of Aruba in 1997 to that in 2000?
Your answer should be very brief. 1. What is the ratio of the Trade (in US$) of Comoros in 1997 to that in 2000?
Make the answer very short. 1.59. What is the ratio of the Trade (in US$) of Macedonia in 1997 to that in 2000?
Your answer should be compact. 1.07. What is the ratio of the Trade (in US$) in Angola in 1997 to that in 2001?
Your answer should be very brief. 0.79. What is the ratio of the Trade (in US$) of Comoros in 1997 to that in 2001?
Make the answer very short. 1.4. What is the ratio of the Trade (in US$) of Macedonia in 1997 to that in 2001?
Your answer should be very brief. 1.21. What is the ratio of the Trade (in US$) of Angola in 1997 to that in 2002?
Offer a very short reply. 0.72. What is the ratio of the Trade (in US$) in Aruba in 1997 to that in 2002?
Provide a succinct answer. 0.98. What is the ratio of the Trade (in US$) of Comoros in 1997 to that in 2002?
Offer a very short reply. 1.31. What is the ratio of the Trade (in US$) in Macedonia in 1997 to that in 2002?
Offer a terse response. 1.04. What is the ratio of the Trade (in US$) in Angola in 1997 to that in 2003?
Offer a terse response. 0.6. What is the ratio of the Trade (in US$) in Aruba in 1997 to that in 2003?
Your answer should be very brief. 0.92. What is the ratio of the Trade (in US$) in Comoros in 1997 to that in 2003?
Ensure brevity in your answer.  0.9. What is the ratio of the Trade (in US$) in Macedonia in 1997 to that in 2003?
Offer a terse response. 0.88. What is the ratio of the Trade (in US$) of Angola in 1997 to that in 2004?
Offer a very short reply. 0.5. What is the ratio of the Trade (in US$) in Aruba in 1997 to that in 2004?
Offer a terse response. 0.86. What is the ratio of the Trade (in US$) in Comoros in 1997 to that in 2004?
Provide a succinct answer. 0.76. What is the ratio of the Trade (in US$) in Macedonia in 1997 to that in 2004?
Offer a very short reply. 0.67. What is the ratio of the Trade (in US$) in Angola in 1998 to that in 1999?
Provide a succinct answer. 0.83. What is the ratio of the Trade (in US$) of Aruba in 1998 to that in 1999?
Provide a short and direct response. 0.96. What is the ratio of the Trade (in US$) in Comoros in 1998 to that in 1999?
Offer a very short reply. 1.06. What is the ratio of the Trade (in US$) of Macedonia in 1998 to that in 1999?
Your response must be concise. 1.05. What is the ratio of the Trade (in US$) in Angola in 1998 to that in 2000?
Offer a terse response. 0.82. What is the ratio of the Trade (in US$) of Aruba in 1998 to that in 2000?
Provide a short and direct response. 1.05. What is the ratio of the Trade (in US$) in Comoros in 1998 to that in 2000?
Keep it short and to the point. 1.4. What is the ratio of the Trade (in US$) in Macedonia in 1998 to that in 2000?
Provide a short and direct response. 1.12. What is the ratio of the Trade (in US$) in Angola in 1998 to that in 2001?
Your answer should be compact. 0.7. What is the ratio of the Trade (in US$) in Aruba in 1998 to that in 2001?
Provide a succinct answer. 1.06. What is the ratio of the Trade (in US$) in Comoros in 1998 to that in 2001?
Make the answer very short. 1.24. What is the ratio of the Trade (in US$) in Macedonia in 1998 to that in 2001?
Offer a very short reply. 1.28. What is the ratio of the Trade (in US$) of Angola in 1998 to that in 2002?
Offer a terse response. 0.64. What is the ratio of the Trade (in US$) in Aruba in 1998 to that in 2002?
Your response must be concise. 1.03. What is the ratio of the Trade (in US$) of Comoros in 1998 to that in 2002?
Provide a short and direct response. 1.15. What is the ratio of the Trade (in US$) in Macedonia in 1998 to that in 2002?
Provide a short and direct response. 1.1. What is the ratio of the Trade (in US$) of Angola in 1998 to that in 2003?
Your answer should be very brief. 0.53. What is the ratio of the Trade (in US$) of Aruba in 1998 to that in 2003?
Provide a short and direct response. 0.97. What is the ratio of the Trade (in US$) of Comoros in 1998 to that in 2003?
Provide a succinct answer. 0.79. What is the ratio of the Trade (in US$) in Macedonia in 1998 to that in 2003?
Your response must be concise. 0.93. What is the ratio of the Trade (in US$) of Angola in 1998 to that in 2004?
Ensure brevity in your answer.  0.44. What is the ratio of the Trade (in US$) in Aruba in 1998 to that in 2004?
Provide a short and direct response. 0.91. What is the ratio of the Trade (in US$) in Comoros in 1998 to that in 2004?
Provide a succinct answer. 0.67. What is the ratio of the Trade (in US$) of Macedonia in 1998 to that in 2004?
Offer a terse response. 0.7. What is the ratio of the Trade (in US$) of Aruba in 1999 to that in 2000?
Offer a terse response. 1.1. What is the ratio of the Trade (in US$) in Comoros in 1999 to that in 2000?
Give a very brief answer. 1.32. What is the ratio of the Trade (in US$) of Macedonia in 1999 to that in 2000?
Your answer should be very brief. 1.08. What is the ratio of the Trade (in US$) of Angola in 1999 to that in 2001?
Make the answer very short. 0.85. What is the ratio of the Trade (in US$) of Aruba in 1999 to that in 2001?
Make the answer very short. 1.11. What is the ratio of the Trade (in US$) of Comoros in 1999 to that in 2001?
Provide a succinct answer. 1.16. What is the ratio of the Trade (in US$) in Macedonia in 1999 to that in 2001?
Ensure brevity in your answer.  1.22. What is the ratio of the Trade (in US$) of Angola in 1999 to that in 2002?
Ensure brevity in your answer.  0.77. What is the ratio of the Trade (in US$) in Aruba in 1999 to that in 2002?
Give a very brief answer. 1.08. What is the ratio of the Trade (in US$) of Comoros in 1999 to that in 2002?
Give a very brief answer. 1.09. What is the ratio of the Trade (in US$) in Macedonia in 1999 to that in 2002?
Provide a succinct answer. 1.05. What is the ratio of the Trade (in US$) in Angola in 1999 to that in 2003?
Offer a very short reply. 0.65. What is the ratio of the Trade (in US$) in Aruba in 1999 to that in 2003?
Provide a short and direct response. 1.02. What is the ratio of the Trade (in US$) of Comoros in 1999 to that in 2003?
Provide a succinct answer. 0.75. What is the ratio of the Trade (in US$) in Macedonia in 1999 to that in 2003?
Your response must be concise. 0.89. What is the ratio of the Trade (in US$) of Angola in 1999 to that in 2004?
Provide a short and direct response. 0.54. What is the ratio of the Trade (in US$) of Aruba in 1999 to that in 2004?
Give a very brief answer. 0.95. What is the ratio of the Trade (in US$) in Comoros in 1999 to that in 2004?
Provide a succinct answer. 0.63. What is the ratio of the Trade (in US$) of Macedonia in 1999 to that in 2004?
Your answer should be compact. 0.67. What is the ratio of the Trade (in US$) of Angola in 2000 to that in 2001?
Your answer should be compact. 0.86. What is the ratio of the Trade (in US$) of Comoros in 2000 to that in 2001?
Your answer should be very brief. 0.88. What is the ratio of the Trade (in US$) in Macedonia in 2000 to that in 2001?
Offer a very short reply. 1.14. What is the ratio of the Trade (in US$) of Angola in 2000 to that in 2002?
Keep it short and to the point. 0.78. What is the ratio of the Trade (in US$) in Aruba in 2000 to that in 2002?
Your response must be concise. 0.98. What is the ratio of the Trade (in US$) in Comoros in 2000 to that in 2002?
Offer a very short reply. 0.82. What is the ratio of the Trade (in US$) in Angola in 2000 to that in 2003?
Make the answer very short. 0.65. What is the ratio of the Trade (in US$) in Aruba in 2000 to that in 2003?
Ensure brevity in your answer.  0.92. What is the ratio of the Trade (in US$) of Comoros in 2000 to that in 2003?
Your answer should be very brief. 0.57. What is the ratio of the Trade (in US$) in Macedonia in 2000 to that in 2003?
Offer a terse response. 0.83. What is the ratio of the Trade (in US$) in Angola in 2000 to that in 2004?
Your response must be concise. 0.54. What is the ratio of the Trade (in US$) in Aruba in 2000 to that in 2004?
Keep it short and to the point. 0.87. What is the ratio of the Trade (in US$) of Comoros in 2000 to that in 2004?
Your answer should be compact. 0.48. What is the ratio of the Trade (in US$) in Macedonia in 2000 to that in 2004?
Provide a short and direct response. 0.62. What is the ratio of the Trade (in US$) of Angola in 2001 to that in 2002?
Offer a terse response. 0.91. What is the ratio of the Trade (in US$) of Aruba in 2001 to that in 2002?
Provide a succinct answer. 0.98. What is the ratio of the Trade (in US$) of Comoros in 2001 to that in 2002?
Offer a terse response. 0.94. What is the ratio of the Trade (in US$) of Macedonia in 2001 to that in 2002?
Provide a short and direct response. 0.86. What is the ratio of the Trade (in US$) of Angola in 2001 to that in 2003?
Ensure brevity in your answer.  0.76. What is the ratio of the Trade (in US$) in Aruba in 2001 to that in 2003?
Provide a succinct answer. 0.92. What is the ratio of the Trade (in US$) of Comoros in 2001 to that in 2003?
Offer a terse response. 0.64. What is the ratio of the Trade (in US$) in Macedonia in 2001 to that in 2003?
Offer a terse response. 0.73. What is the ratio of the Trade (in US$) of Angola in 2001 to that in 2004?
Offer a terse response. 0.63. What is the ratio of the Trade (in US$) in Aruba in 2001 to that in 2004?
Ensure brevity in your answer.  0.86. What is the ratio of the Trade (in US$) of Comoros in 2001 to that in 2004?
Provide a succinct answer. 0.54. What is the ratio of the Trade (in US$) in Macedonia in 2001 to that in 2004?
Offer a terse response. 0.55. What is the ratio of the Trade (in US$) in Angola in 2002 to that in 2003?
Make the answer very short. 0.83. What is the ratio of the Trade (in US$) in Aruba in 2002 to that in 2003?
Give a very brief answer. 0.94. What is the ratio of the Trade (in US$) in Comoros in 2002 to that in 2003?
Provide a succinct answer. 0.69. What is the ratio of the Trade (in US$) of Macedonia in 2002 to that in 2003?
Your answer should be compact. 0.85. What is the ratio of the Trade (in US$) in Angola in 2002 to that in 2004?
Provide a short and direct response. 0.69. What is the ratio of the Trade (in US$) of Aruba in 2002 to that in 2004?
Offer a very short reply. 0.88. What is the ratio of the Trade (in US$) of Comoros in 2002 to that in 2004?
Offer a very short reply. 0.58. What is the ratio of the Trade (in US$) of Macedonia in 2002 to that in 2004?
Ensure brevity in your answer.  0.64. What is the ratio of the Trade (in US$) in Angola in 2003 to that in 2004?
Your answer should be very brief. 0.83. What is the ratio of the Trade (in US$) in Aruba in 2003 to that in 2004?
Keep it short and to the point. 0.94. What is the ratio of the Trade (in US$) in Comoros in 2003 to that in 2004?
Your answer should be compact. 0.85. What is the ratio of the Trade (in US$) of Macedonia in 2003 to that in 2004?
Your answer should be very brief. 0.75. What is the difference between the highest and the second highest Trade (in US$) of Angola?
Your answer should be very brief. 1.81e+09. What is the difference between the highest and the second highest Trade (in US$) of Aruba?
Your answer should be very brief. 6.98e+07. What is the difference between the highest and the second highest Trade (in US$) of Comoros?
Your answer should be very brief. 1.83e+07. What is the difference between the highest and the second highest Trade (in US$) of Macedonia?
Ensure brevity in your answer.  7.03e+08. What is the difference between the highest and the lowest Trade (in US$) of Angola?
Your answer should be very brief. 5.93e+09. What is the difference between the highest and the lowest Trade (in US$) of Aruba?
Offer a very short reply. 2.12e+08. What is the difference between the highest and the lowest Trade (in US$) in Comoros?
Your answer should be compact. 6.22e+07. What is the difference between the highest and the lowest Trade (in US$) in Macedonia?
Offer a very short reply. 1.28e+09. 